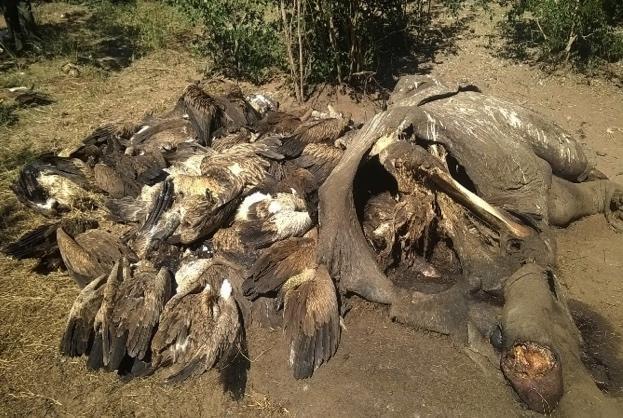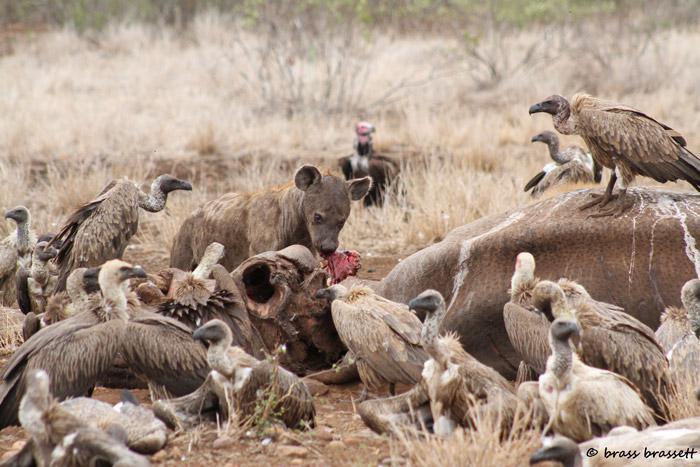The first image is the image on the left, the second image is the image on the right. Evaluate the accuracy of this statement regarding the images: "there is a hyena in the image on the right.". Is it true? Answer yes or no. Yes. The first image is the image on the left, the second image is the image on the right. Analyze the images presented: Is the assertion "In the right image, at least one hyena is present along with vultures." valid? Answer yes or no. Yes. 